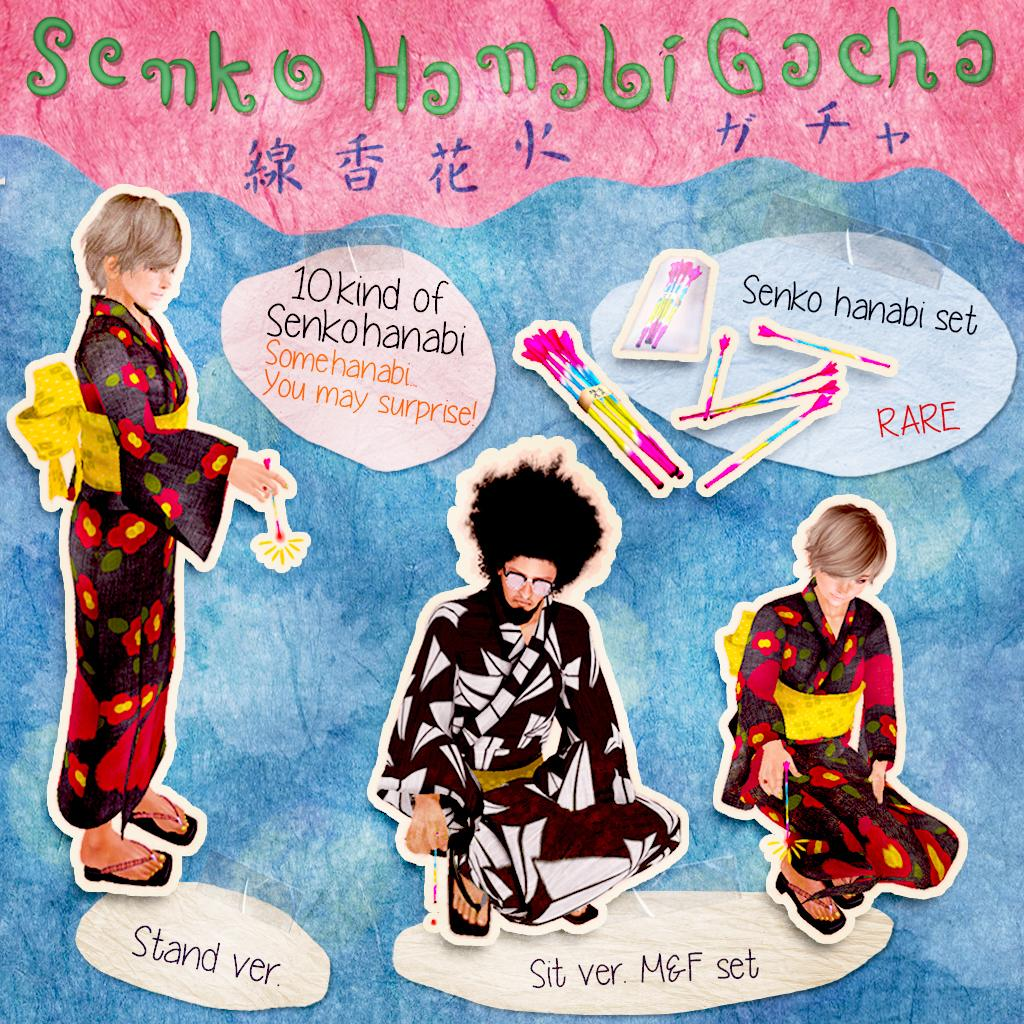What type of artwork is depicted in the image? The image is a painting. Can you describe the main subject of the painting? There are three persons in the center of the painting. What additional elements can be seen on the painting? Stickers have been passed on the painting, and there is writing on the painting. What type of seed is growing in the painting? There is no seed growing in the painting; the image is a painting of three persons with stickers and writing on it. 